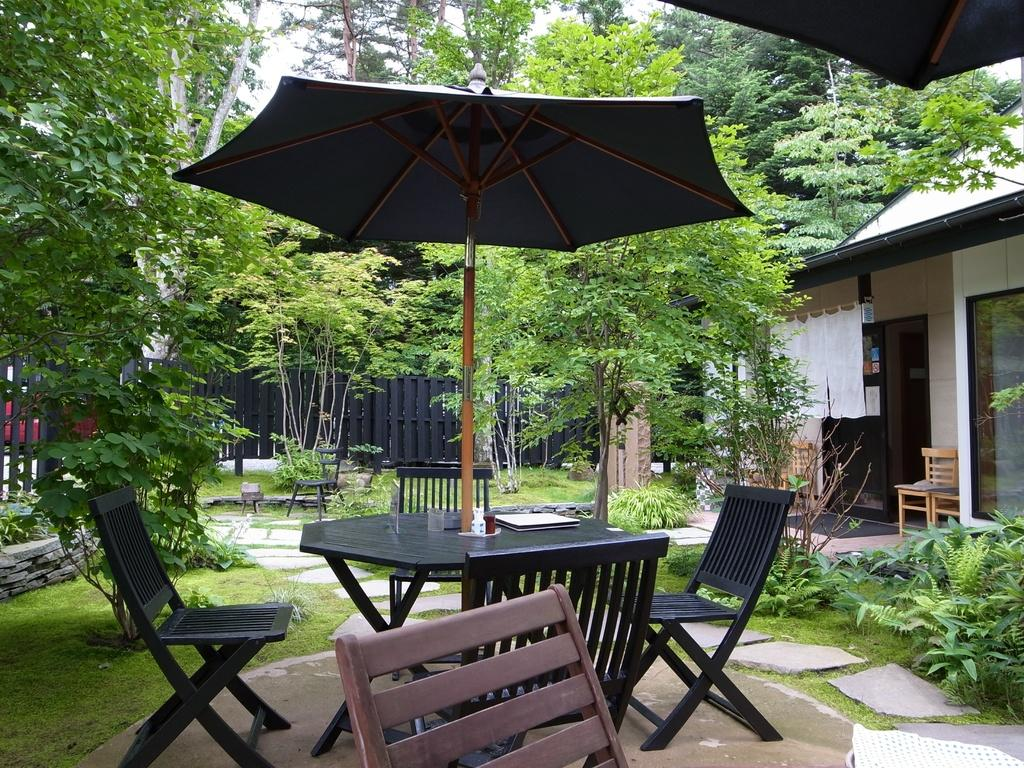What type of furniture is present in the image? There are chairs and a table in the image. What is attached to the pole on the table? There is an umbrella on the pole on the table. What type of vegetation can be seen in the image? Plants, grass, and trees are visible in the image. What type of material is used for the flooring in the image? Bricks are visible in the image, which suggests they might be used for flooring. What structure is present in the image? There is a house in the image. What part of the natural environment is visible in the image? The sky is visible in the image. What type of cart is being used to transport the sun in the image? There is no cart or sun present in the image. What type of learning activity is taking place in the image? There is no learning activity depicted in the image. 